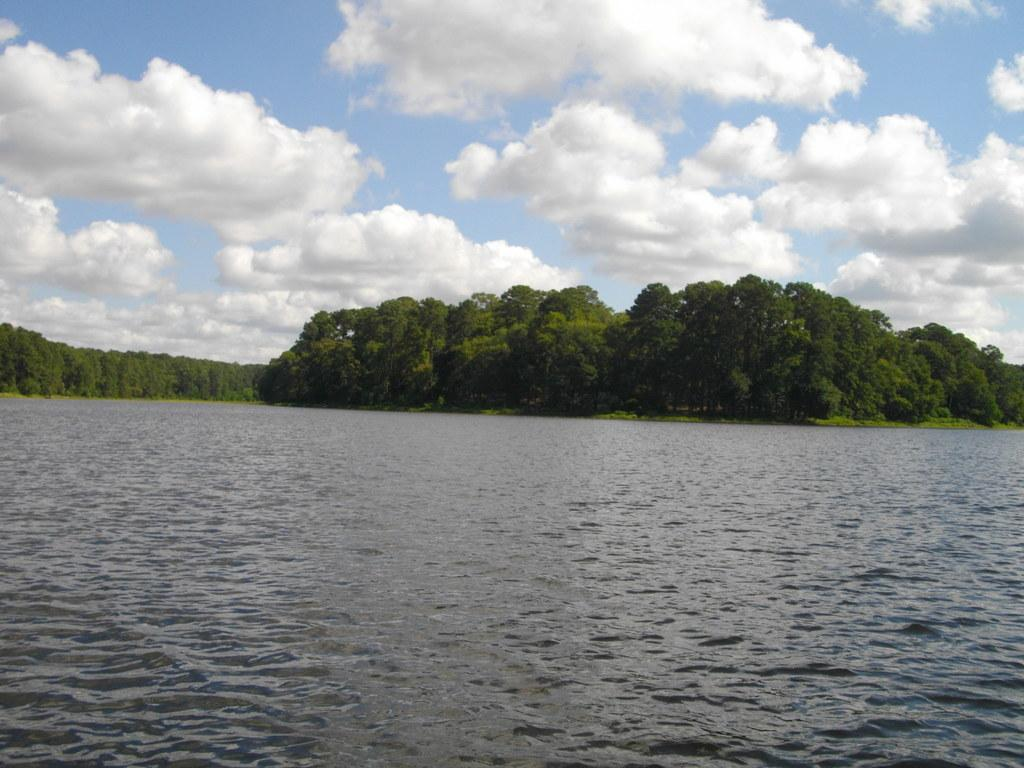What type of natural environment is depicted in the image? There is a sea in the image. What can be seen in the distance behind the sea? There are trees in the background of the image. How would you describe the weather in the image? The sky is cloudy in the image. What type of pot or jar is visible in the image? There is no pot or jar present in the image. What color is the sheet draped over the sea in the image? There is no sheet present in the image; it is a natural scene with a sea, trees, and a cloudy sky. 